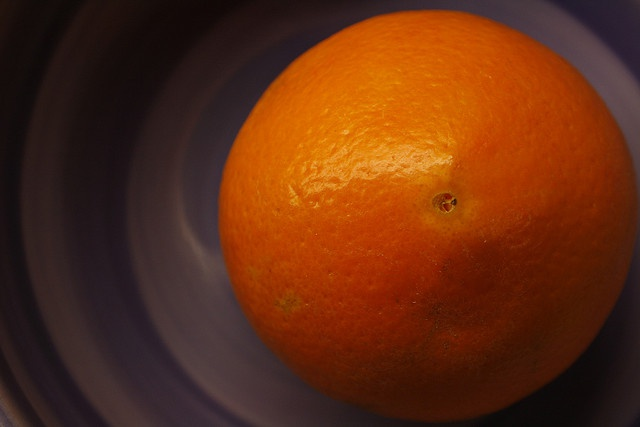Describe the objects in this image and their specific colors. I can see bowl in black, maroon, and red tones and orange in black, maroon, and red tones in this image. 